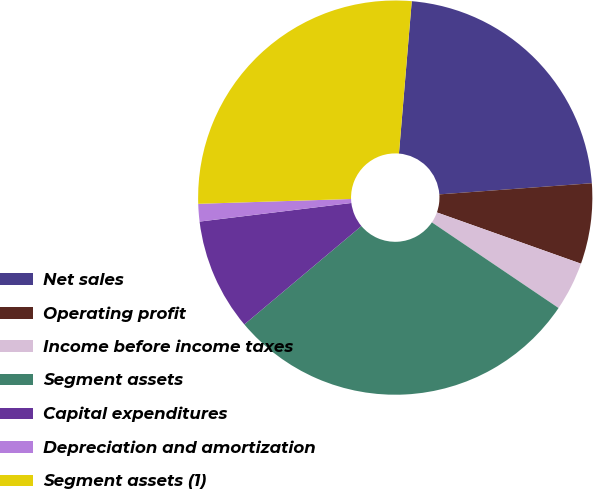Convert chart. <chart><loc_0><loc_0><loc_500><loc_500><pie_chart><fcel>Net sales<fcel>Operating profit<fcel>Income before income taxes<fcel>Segment assets<fcel>Capital expenditures<fcel>Depreciation and amortization<fcel>Segment assets (1)<nl><fcel>22.5%<fcel>6.6%<fcel>4.02%<fcel>29.41%<fcel>9.18%<fcel>1.44%<fcel>26.83%<nl></chart> 